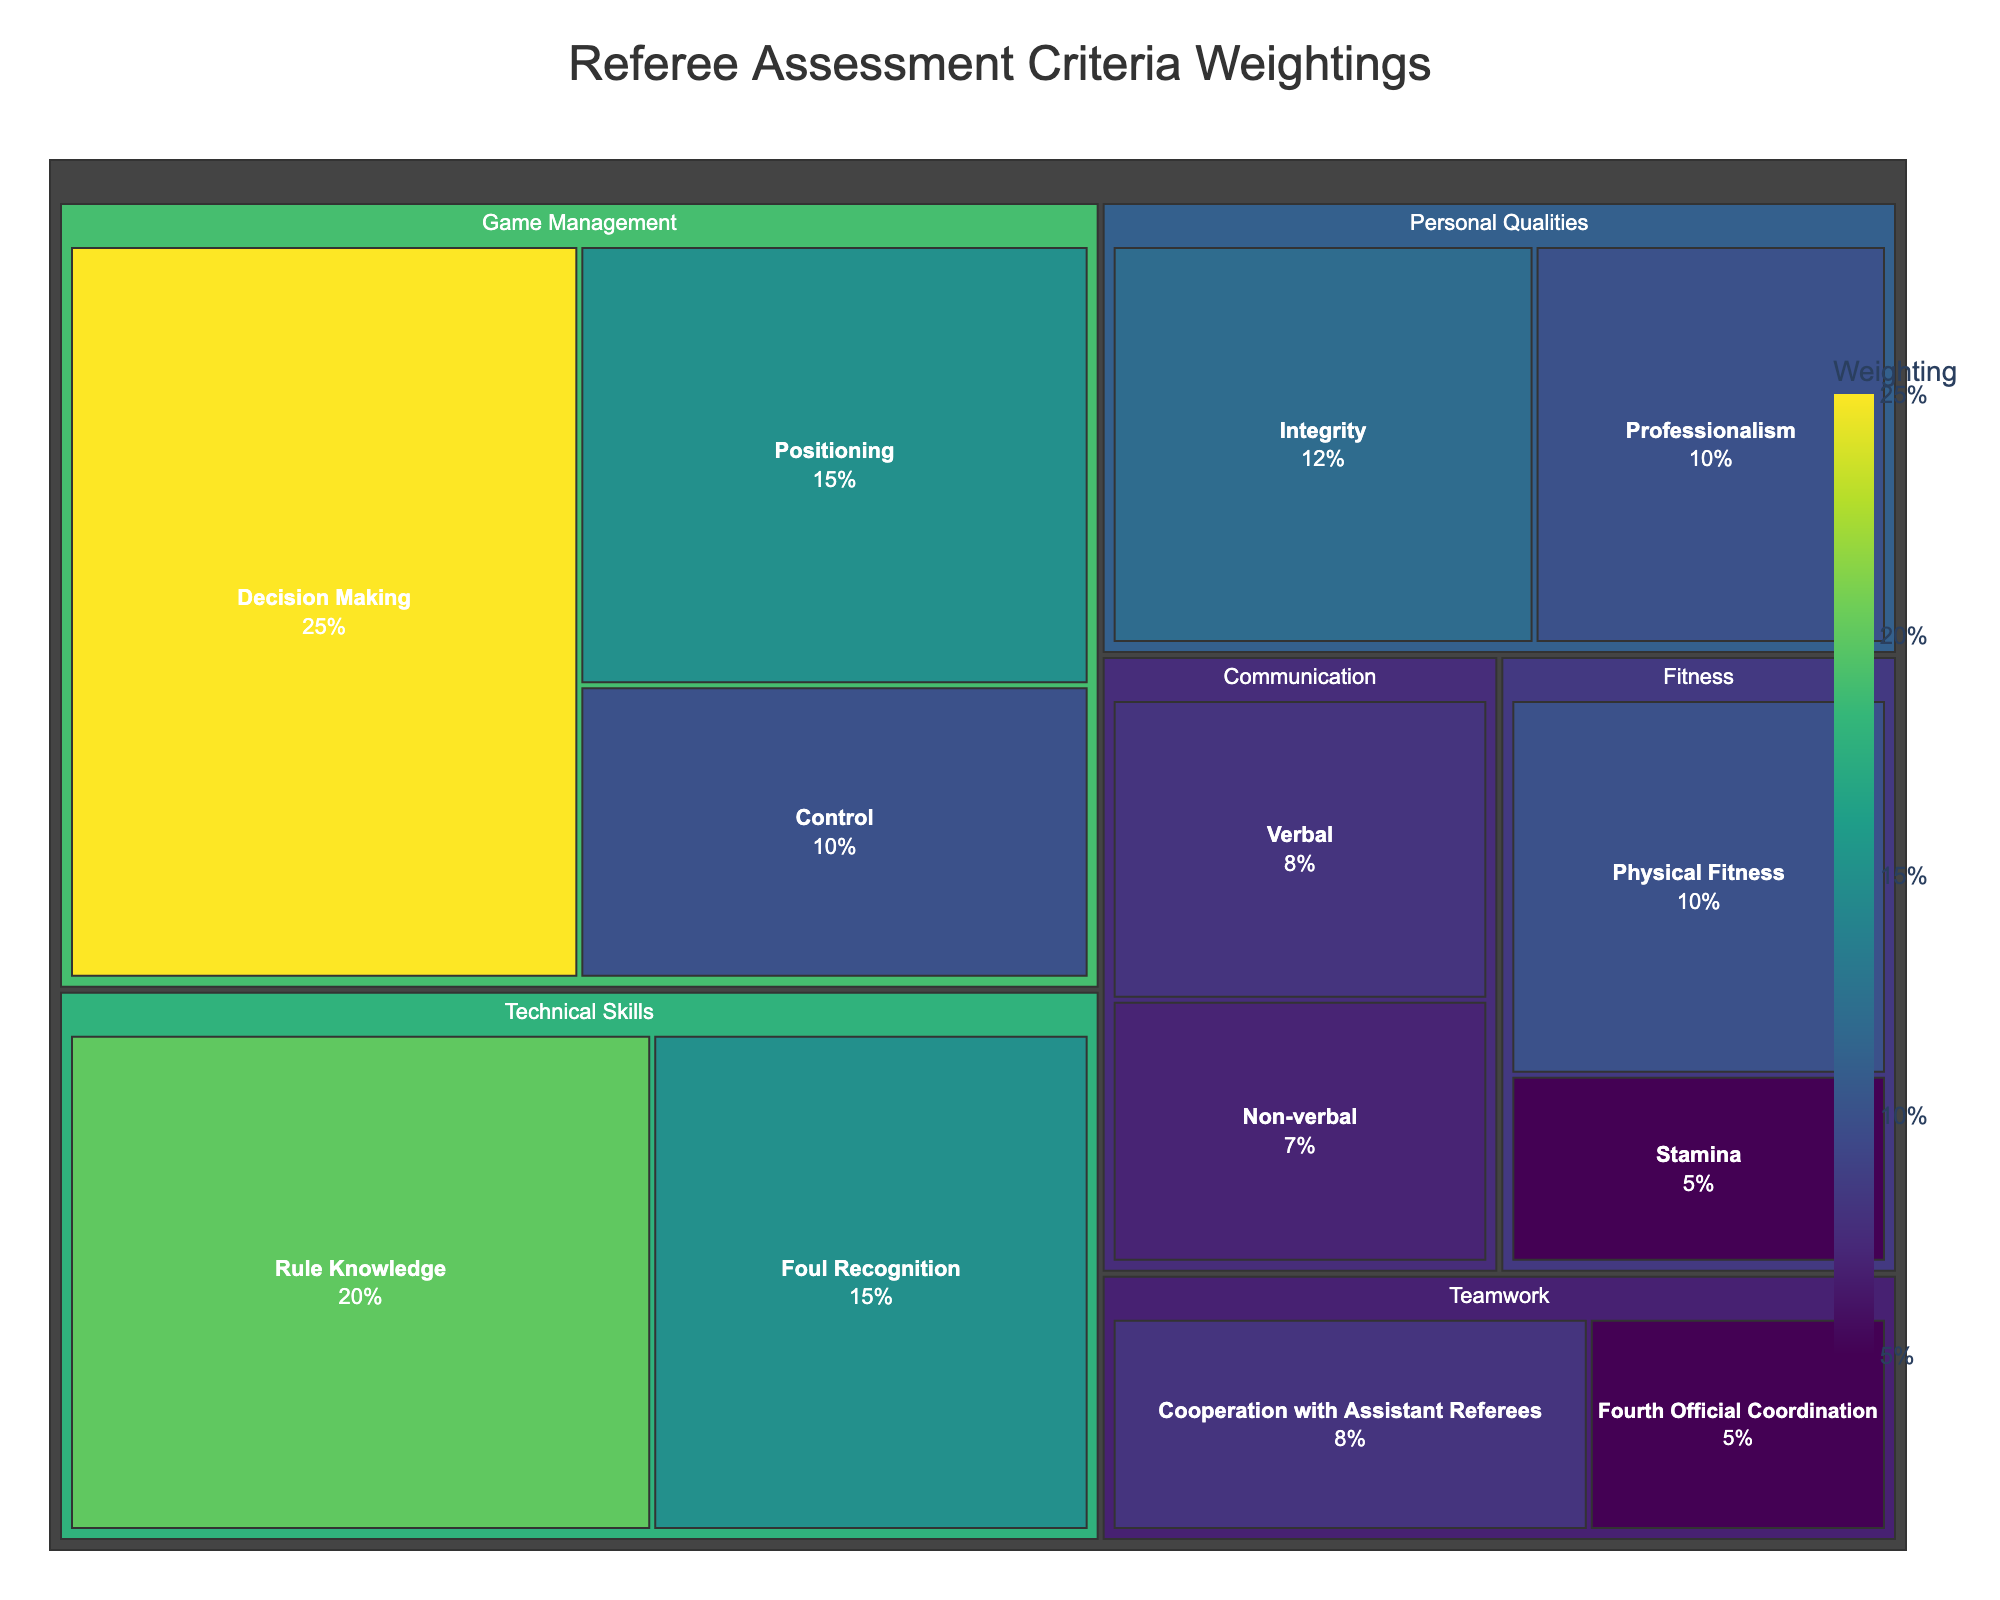What's the highest weighted subcategory in "Game Management"? Locate the "Game Management" category in the treemap and identify the largest percentage value among its subcategories. The highest is 25% for Decision Making.
Answer: Decision Making What's the combined weighting of all subcategories in "Fitness"? Locate the "Fitness" category and add up the values of its subcategories, which are Physical Fitness (10%) and Stamina (5%). The total is 10 + 5 = 15%.
Answer: 15% Which category has the least total weighting? Compare the sum of the subcategory values for each category. The one with the smallest combined value is "Communication," with a total of 8% (Verbal) + 7% (Non-verbal) = 15%.
Answer: Communication How much higher is the weighting for "Professionalism" compared to "Stamina"? Find the values for Professionalism (10%) and Stamina (5%) and calculate the difference. 10 - 5 = 5%.
Answer: 5% Is "Rule Knowledge" weighted more heavily than "Control"? Compare the weighting values of Rule Knowledge (20%) and Control (10%). Since 20% is greater than 10%, Rule Knowledge is weighted more heavily.
Answer: Yes What's the total weighting of all subcategories in "Technical Skills"? Sum the values of each subcategory in the "Technical Skills" category: Rule Knowledge (20%) + Foul Recognition (15%) = 35%.
Answer: 35% Which subcategory has the smallest value? Identify the subcategory with the lowest percentage in the entire treemap. Fourth Official Coordination has the smallest value at 5%.
Answer: Fourth Official Coordination How does the weighting of "Integrity" compare to the combined weighting of "Verbal" and "Non-verbal" in Communication? Integrity is 12%, and the combined weighting of Verbal and Non-verbal is 8% + 7% = 15%. So, Integrity is less than Communication.
Answer: Less What's the weighting ratio between "Rule Knowledge" and "Positioning"? Divide the value of Rule Knowledge (20%) by Positioning (15%) to get the ratio: 20 / 15 = 1.33.
Answer: 1.33 What’s the sum of the weightings for all subcategories in "Teamwork"? Locate the "Teamwork" category and sum the subcategories: Cooperation with Assistant Referees (8%) + Fourth Official Coordination (5%) = 13%.
Answer: 13% 